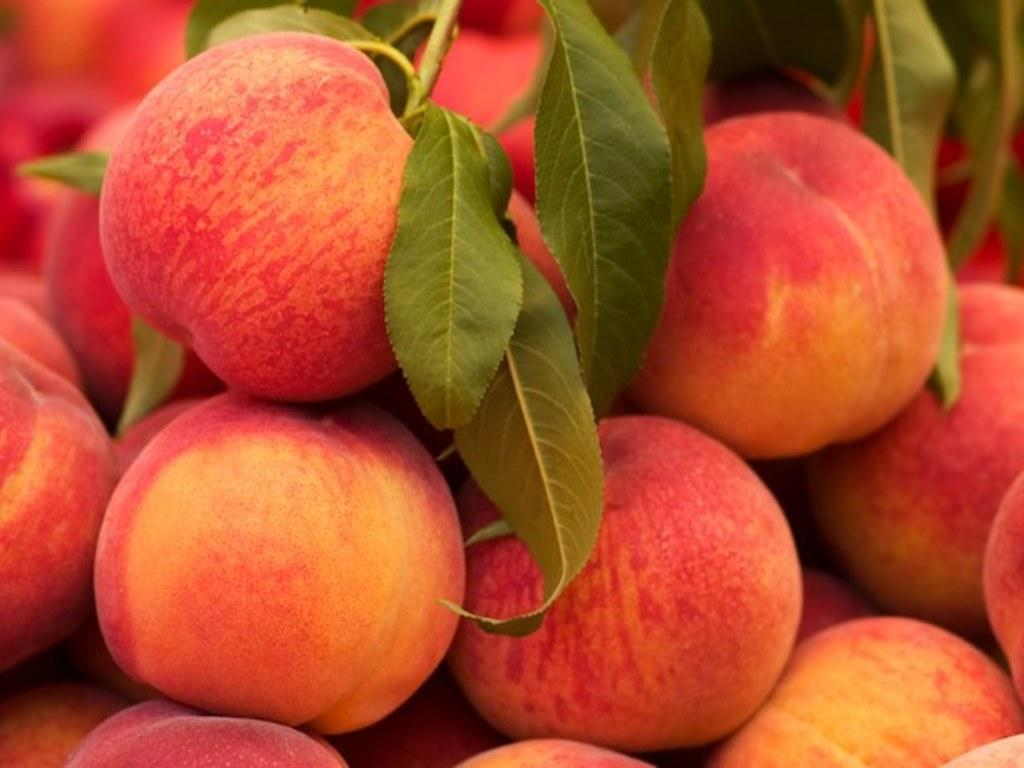What type of fruit is present in the image? There are apples in the image. Where are the apples located in the image? The apples are in the center of the image. What color are the apples? The apples are red in color. Can you see any balls bursting on the seashore in the image? There is no seashore, balls, or bursting events present in the image; it features apples in the center. 